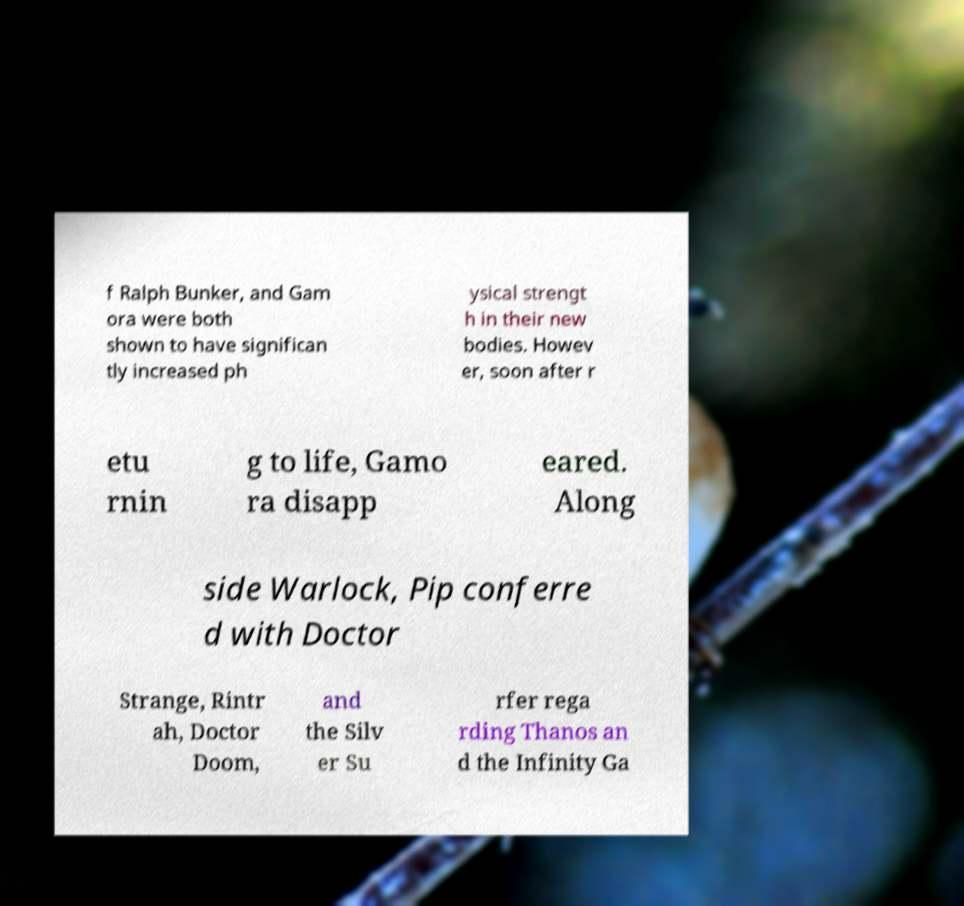What messages or text are displayed in this image? I need them in a readable, typed format. f Ralph Bunker, and Gam ora were both shown to have significan tly increased ph ysical strengt h in their new bodies. Howev er, soon after r etu rnin g to life, Gamo ra disapp eared. Along side Warlock, Pip conferre d with Doctor Strange, Rintr ah, Doctor Doom, and the Silv er Su rfer rega rding Thanos an d the Infinity Ga 